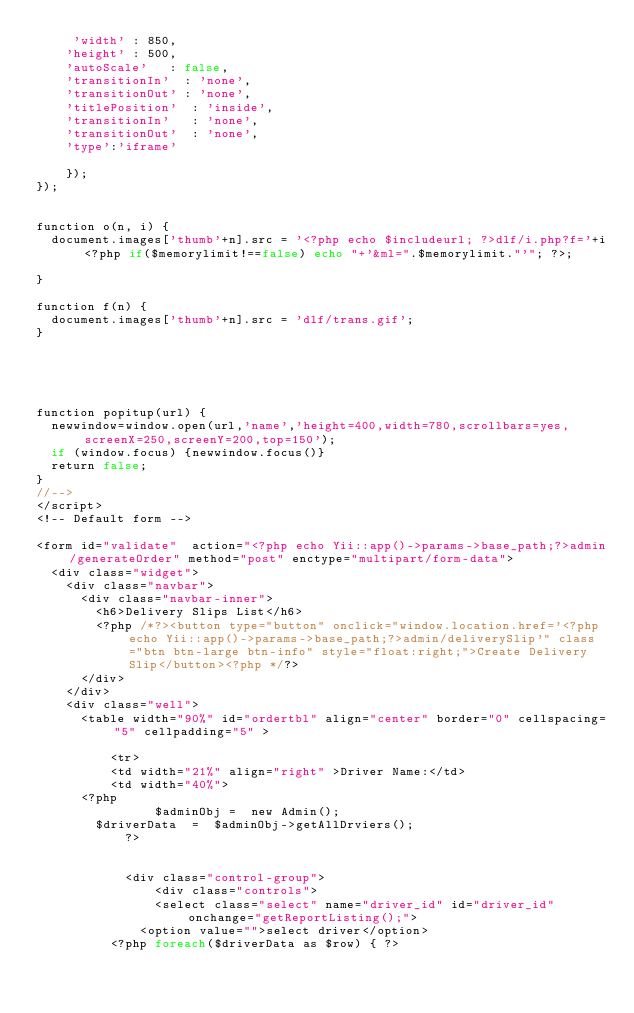Convert code to text. <code><loc_0><loc_0><loc_500><loc_500><_PHP_>		 'width' : 850,
 		'height' : 500,
		'autoScale'		: false,
		'transitionIn'	: 'none',
		'transitionOut'	: 'none',
		'titlePosition'	 : 'inside',
		'transitionIn'	 : 'none',
		'transitionOut'	 : 'none',
		'type':'iframe'	
	  
	  });
});


function o(n, i) {
	document.images['thumb'+n].src = '<?php echo $includeurl; ?>dlf/i.php?f='+i<?php if($memorylimit!==false) echo "+'&ml=".$memorylimit."'"; ?>;

}

function f(n) {
	document.images['thumb'+n].src = 'dlf/trans.gif';
}

	



function popitup(url) {
	newwindow=window.open(url,'name','height=400,width=780,scrollbars=yes,screenX=250,screenY=200,top=150');
	if (window.focus) {newwindow.focus()}
	return false;
}
//-->
</script>
<!-- Default form -->

<form id="validate"  action="<?php echo Yii::app()->params->base_path;?>admin/generateOrder" method="post" enctype="multipart/form-data">
  <div class="widget">
    <div class="navbar">
      <div class="navbar-inner">
        <h6>Delivery Slips List</h6>
        <?php /*?><button type="button" onclick="window.location.href='<?php echo Yii::app()->params->base_path;?>admin/deliverySlip'" class="btn btn-large btn-info" style="float:right;">Create Delivery Slip</button><?php */?>
      </div>
    </div>
    <div class="well">
      <table width="90%" id="ordertbl" align="center" border="0" cellspacing="5" cellpadding="5" >
         
          <tr>
          <td width="21%" align="right" >Driver Name:</td>
          <td width="40%">
			<?php 
                $adminObj =  new Admin();
				$driverData  =  $adminObj->getAllDrviers();
            ?>
			

            <div class="control-group">
                <div class="controls">
                <select class="select" name="driver_id" id="driver_id" onchange="getReportListing();">
         			<option value="">select driver</option>
					<?php foreach($driverData as $row) { ?>
                    </code> 